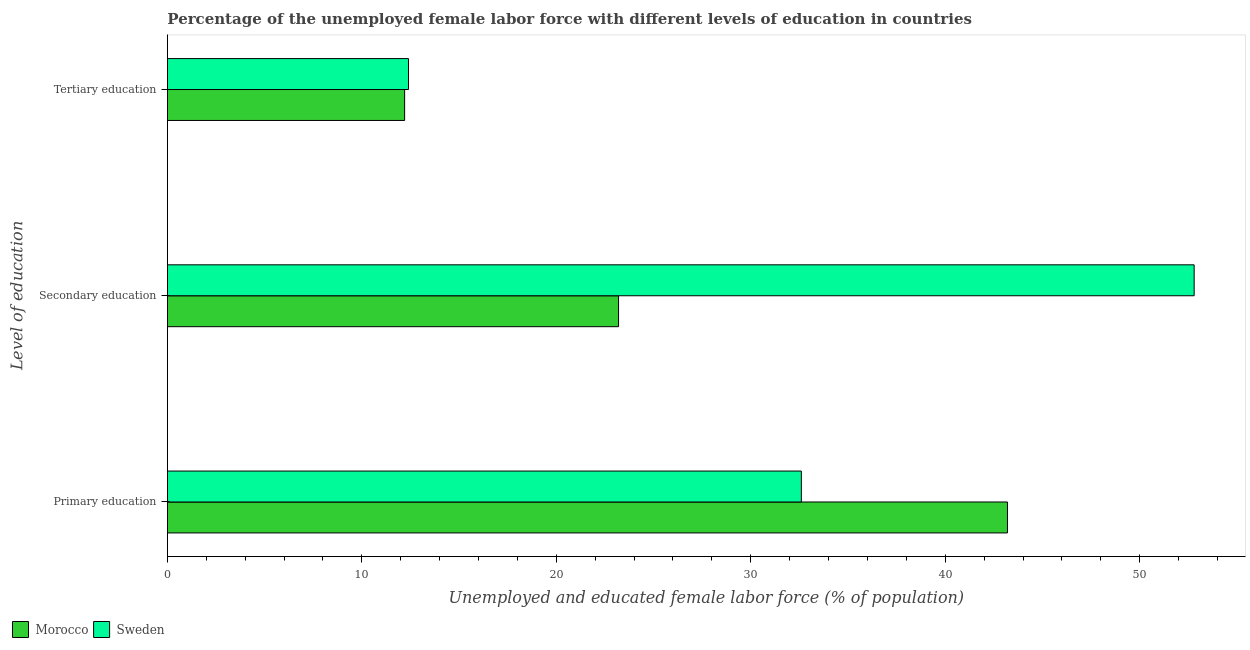How many groups of bars are there?
Provide a short and direct response. 3. Are the number of bars on each tick of the Y-axis equal?
Make the answer very short. Yes. How many bars are there on the 3rd tick from the top?
Ensure brevity in your answer.  2. How many bars are there on the 1st tick from the bottom?
Offer a terse response. 2. What is the percentage of female labor force who received secondary education in Morocco?
Your answer should be very brief. 23.2. Across all countries, what is the maximum percentage of female labor force who received primary education?
Your response must be concise. 43.2. Across all countries, what is the minimum percentage of female labor force who received secondary education?
Provide a short and direct response. 23.2. In which country was the percentage of female labor force who received tertiary education minimum?
Your response must be concise. Morocco. What is the total percentage of female labor force who received primary education in the graph?
Your answer should be compact. 75.8. What is the difference between the percentage of female labor force who received tertiary education in Morocco and that in Sweden?
Provide a short and direct response. -0.2. What is the difference between the percentage of female labor force who received secondary education in Sweden and the percentage of female labor force who received primary education in Morocco?
Offer a terse response. 9.6. What is the average percentage of female labor force who received secondary education per country?
Offer a terse response. 38. What is the difference between the percentage of female labor force who received primary education and percentage of female labor force who received tertiary education in Morocco?
Give a very brief answer. 31. What is the ratio of the percentage of female labor force who received secondary education in Sweden to that in Morocco?
Offer a terse response. 2.28. What is the difference between the highest and the second highest percentage of female labor force who received primary education?
Your answer should be very brief. 10.6. What is the difference between the highest and the lowest percentage of female labor force who received primary education?
Provide a succinct answer. 10.6. What does the 1st bar from the bottom in Primary education represents?
Make the answer very short. Morocco. Is it the case that in every country, the sum of the percentage of female labor force who received primary education and percentage of female labor force who received secondary education is greater than the percentage of female labor force who received tertiary education?
Offer a very short reply. Yes. How many bars are there?
Your answer should be very brief. 6. How many countries are there in the graph?
Offer a very short reply. 2. What is the difference between two consecutive major ticks on the X-axis?
Offer a terse response. 10. How many legend labels are there?
Ensure brevity in your answer.  2. How are the legend labels stacked?
Make the answer very short. Horizontal. What is the title of the graph?
Your response must be concise. Percentage of the unemployed female labor force with different levels of education in countries. What is the label or title of the X-axis?
Give a very brief answer. Unemployed and educated female labor force (% of population). What is the label or title of the Y-axis?
Offer a very short reply. Level of education. What is the Unemployed and educated female labor force (% of population) of Morocco in Primary education?
Provide a succinct answer. 43.2. What is the Unemployed and educated female labor force (% of population) in Sweden in Primary education?
Offer a very short reply. 32.6. What is the Unemployed and educated female labor force (% of population) in Morocco in Secondary education?
Your answer should be very brief. 23.2. What is the Unemployed and educated female labor force (% of population) of Sweden in Secondary education?
Provide a short and direct response. 52.8. What is the Unemployed and educated female labor force (% of population) in Morocco in Tertiary education?
Your answer should be compact. 12.2. What is the Unemployed and educated female labor force (% of population) in Sweden in Tertiary education?
Keep it short and to the point. 12.4. Across all Level of education, what is the maximum Unemployed and educated female labor force (% of population) in Morocco?
Offer a terse response. 43.2. Across all Level of education, what is the maximum Unemployed and educated female labor force (% of population) of Sweden?
Make the answer very short. 52.8. Across all Level of education, what is the minimum Unemployed and educated female labor force (% of population) of Morocco?
Offer a terse response. 12.2. Across all Level of education, what is the minimum Unemployed and educated female labor force (% of population) of Sweden?
Make the answer very short. 12.4. What is the total Unemployed and educated female labor force (% of population) in Morocco in the graph?
Your response must be concise. 78.6. What is the total Unemployed and educated female labor force (% of population) in Sweden in the graph?
Ensure brevity in your answer.  97.8. What is the difference between the Unemployed and educated female labor force (% of population) in Sweden in Primary education and that in Secondary education?
Your response must be concise. -20.2. What is the difference between the Unemployed and educated female labor force (% of population) of Morocco in Primary education and that in Tertiary education?
Ensure brevity in your answer.  31. What is the difference between the Unemployed and educated female labor force (% of population) in Sweden in Primary education and that in Tertiary education?
Give a very brief answer. 20.2. What is the difference between the Unemployed and educated female labor force (% of population) of Sweden in Secondary education and that in Tertiary education?
Keep it short and to the point. 40.4. What is the difference between the Unemployed and educated female labor force (% of population) in Morocco in Primary education and the Unemployed and educated female labor force (% of population) in Sweden in Tertiary education?
Provide a short and direct response. 30.8. What is the average Unemployed and educated female labor force (% of population) of Morocco per Level of education?
Offer a very short reply. 26.2. What is the average Unemployed and educated female labor force (% of population) in Sweden per Level of education?
Provide a succinct answer. 32.6. What is the difference between the Unemployed and educated female labor force (% of population) in Morocco and Unemployed and educated female labor force (% of population) in Sweden in Primary education?
Keep it short and to the point. 10.6. What is the difference between the Unemployed and educated female labor force (% of population) in Morocco and Unemployed and educated female labor force (% of population) in Sweden in Secondary education?
Your answer should be very brief. -29.6. What is the difference between the Unemployed and educated female labor force (% of population) of Morocco and Unemployed and educated female labor force (% of population) of Sweden in Tertiary education?
Provide a short and direct response. -0.2. What is the ratio of the Unemployed and educated female labor force (% of population) in Morocco in Primary education to that in Secondary education?
Give a very brief answer. 1.86. What is the ratio of the Unemployed and educated female labor force (% of population) of Sweden in Primary education to that in Secondary education?
Keep it short and to the point. 0.62. What is the ratio of the Unemployed and educated female labor force (% of population) in Morocco in Primary education to that in Tertiary education?
Ensure brevity in your answer.  3.54. What is the ratio of the Unemployed and educated female labor force (% of population) in Sweden in Primary education to that in Tertiary education?
Keep it short and to the point. 2.63. What is the ratio of the Unemployed and educated female labor force (% of population) in Morocco in Secondary education to that in Tertiary education?
Make the answer very short. 1.9. What is the ratio of the Unemployed and educated female labor force (% of population) in Sweden in Secondary education to that in Tertiary education?
Keep it short and to the point. 4.26. What is the difference between the highest and the second highest Unemployed and educated female labor force (% of population) of Morocco?
Your answer should be very brief. 20. What is the difference between the highest and the second highest Unemployed and educated female labor force (% of population) in Sweden?
Make the answer very short. 20.2. What is the difference between the highest and the lowest Unemployed and educated female labor force (% of population) of Sweden?
Provide a short and direct response. 40.4. 